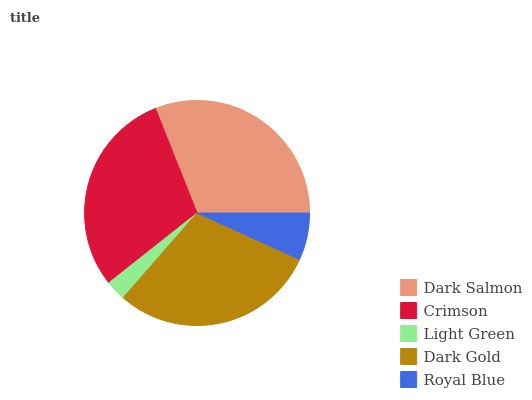Is Light Green the minimum?
Answer yes or no. Yes. Is Dark Salmon the maximum?
Answer yes or no. Yes. Is Crimson the minimum?
Answer yes or no. No. Is Crimson the maximum?
Answer yes or no. No. Is Dark Salmon greater than Crimson?
Answer yes or no. Yes. Is Crimson less than Dark Salmon?
Answer yes or no. Yes. Is Crimson greater than Dark Salmon?
Answer yes or no. No. Is Dark Salmon less than Crimson?
Answer yes or no. No. Is Crimson the high median?
Answer yes or no. Yes. Is Crimson the low median?
Answer yes or no. Yes. Is Dark Salmon the high median?
Answer yes or no. No. Is Dark Gold the low median?
Answer yes or no. No. 